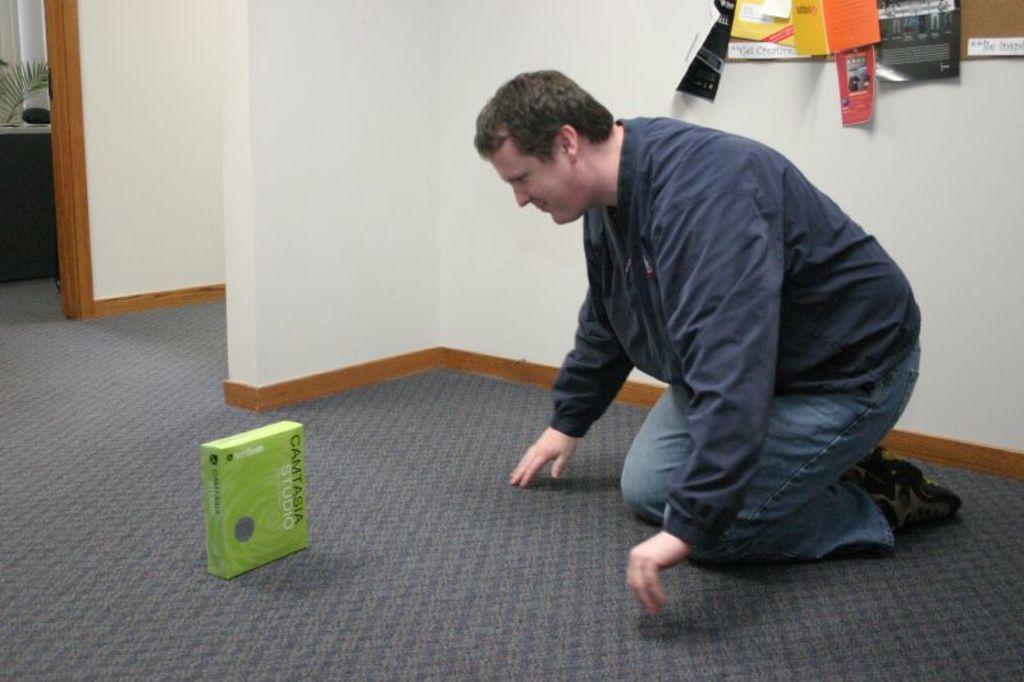How would you summarize this image in a sentence or two? This picture is clicked inside the room. The man in black jacket is smiling. In front of him, we see a green color box which is placed on the grey color floor. Behind him, we see a white wall and many things in black, yellow and orange color are placed beside the window. On the left side, we see a flower pot, a table and a white pillar. 